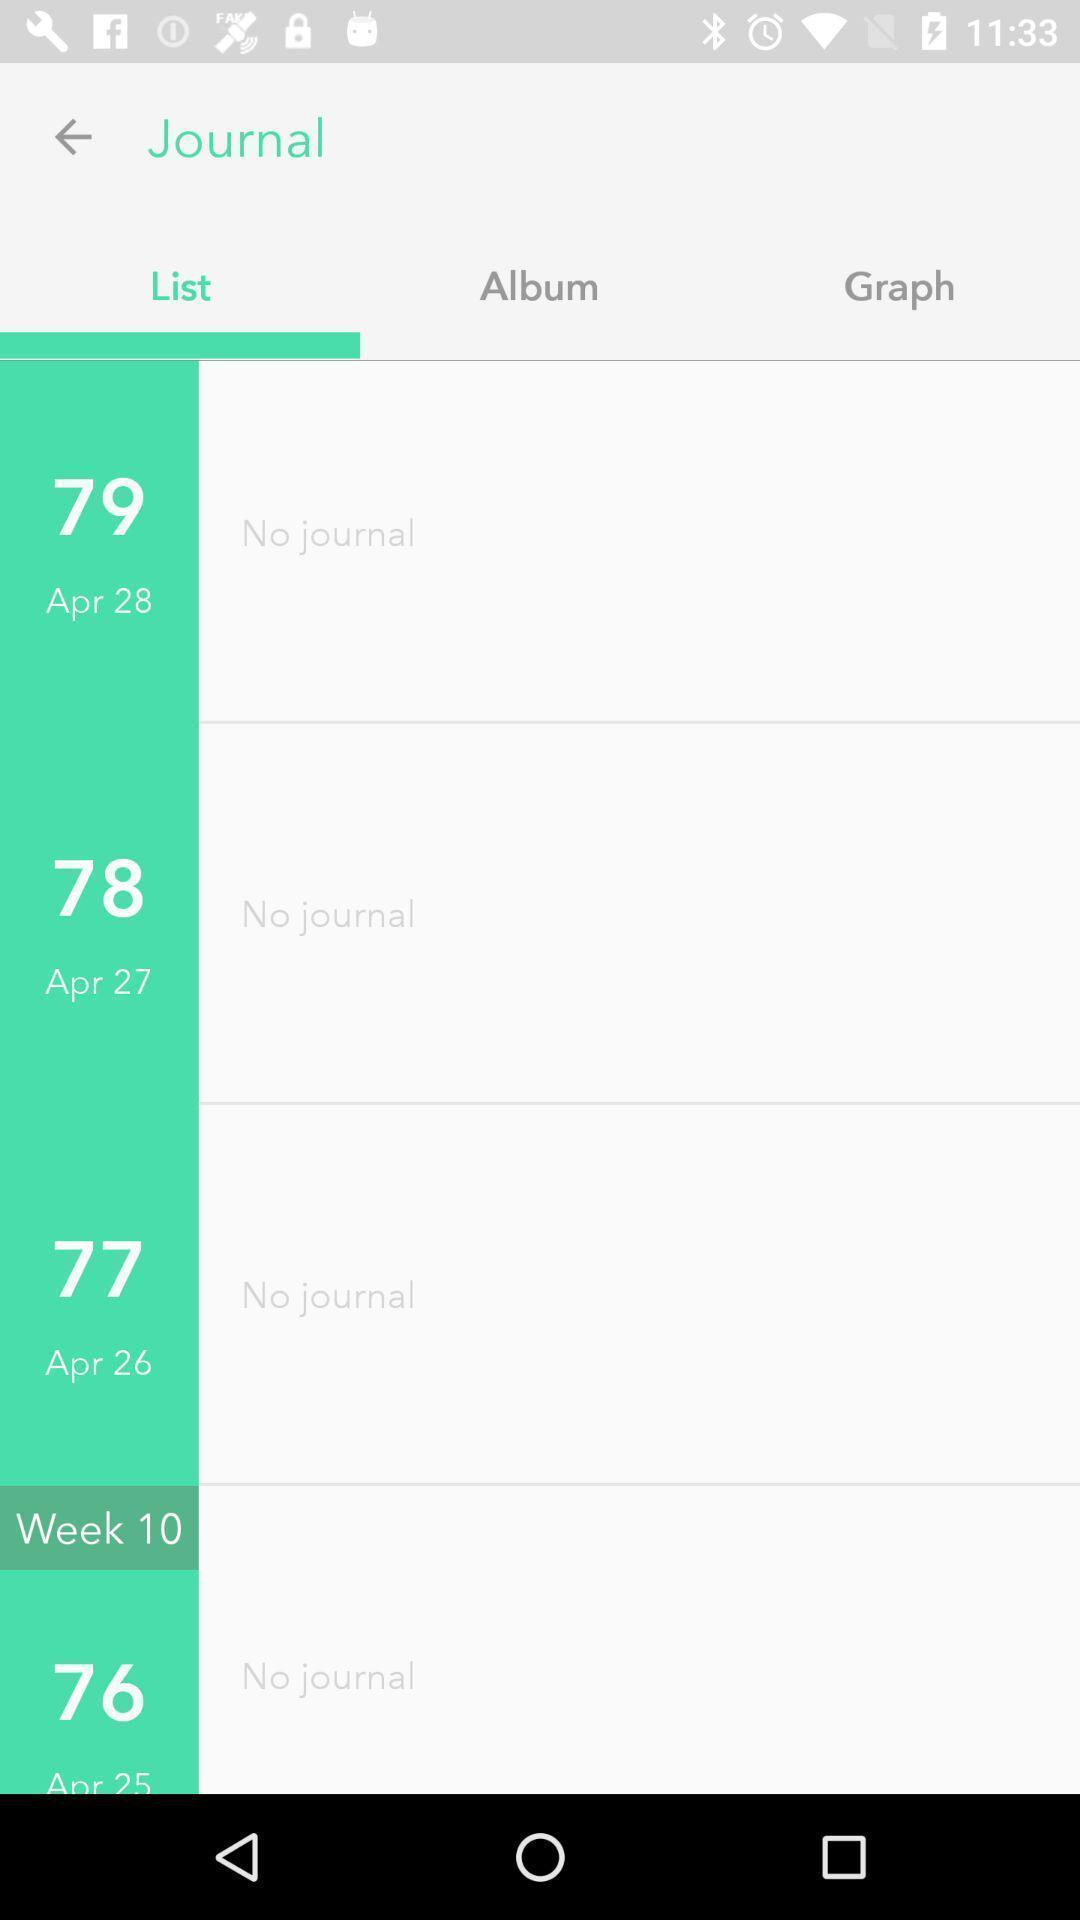What details can you identify in this image? Screen shows journal list on a device. 